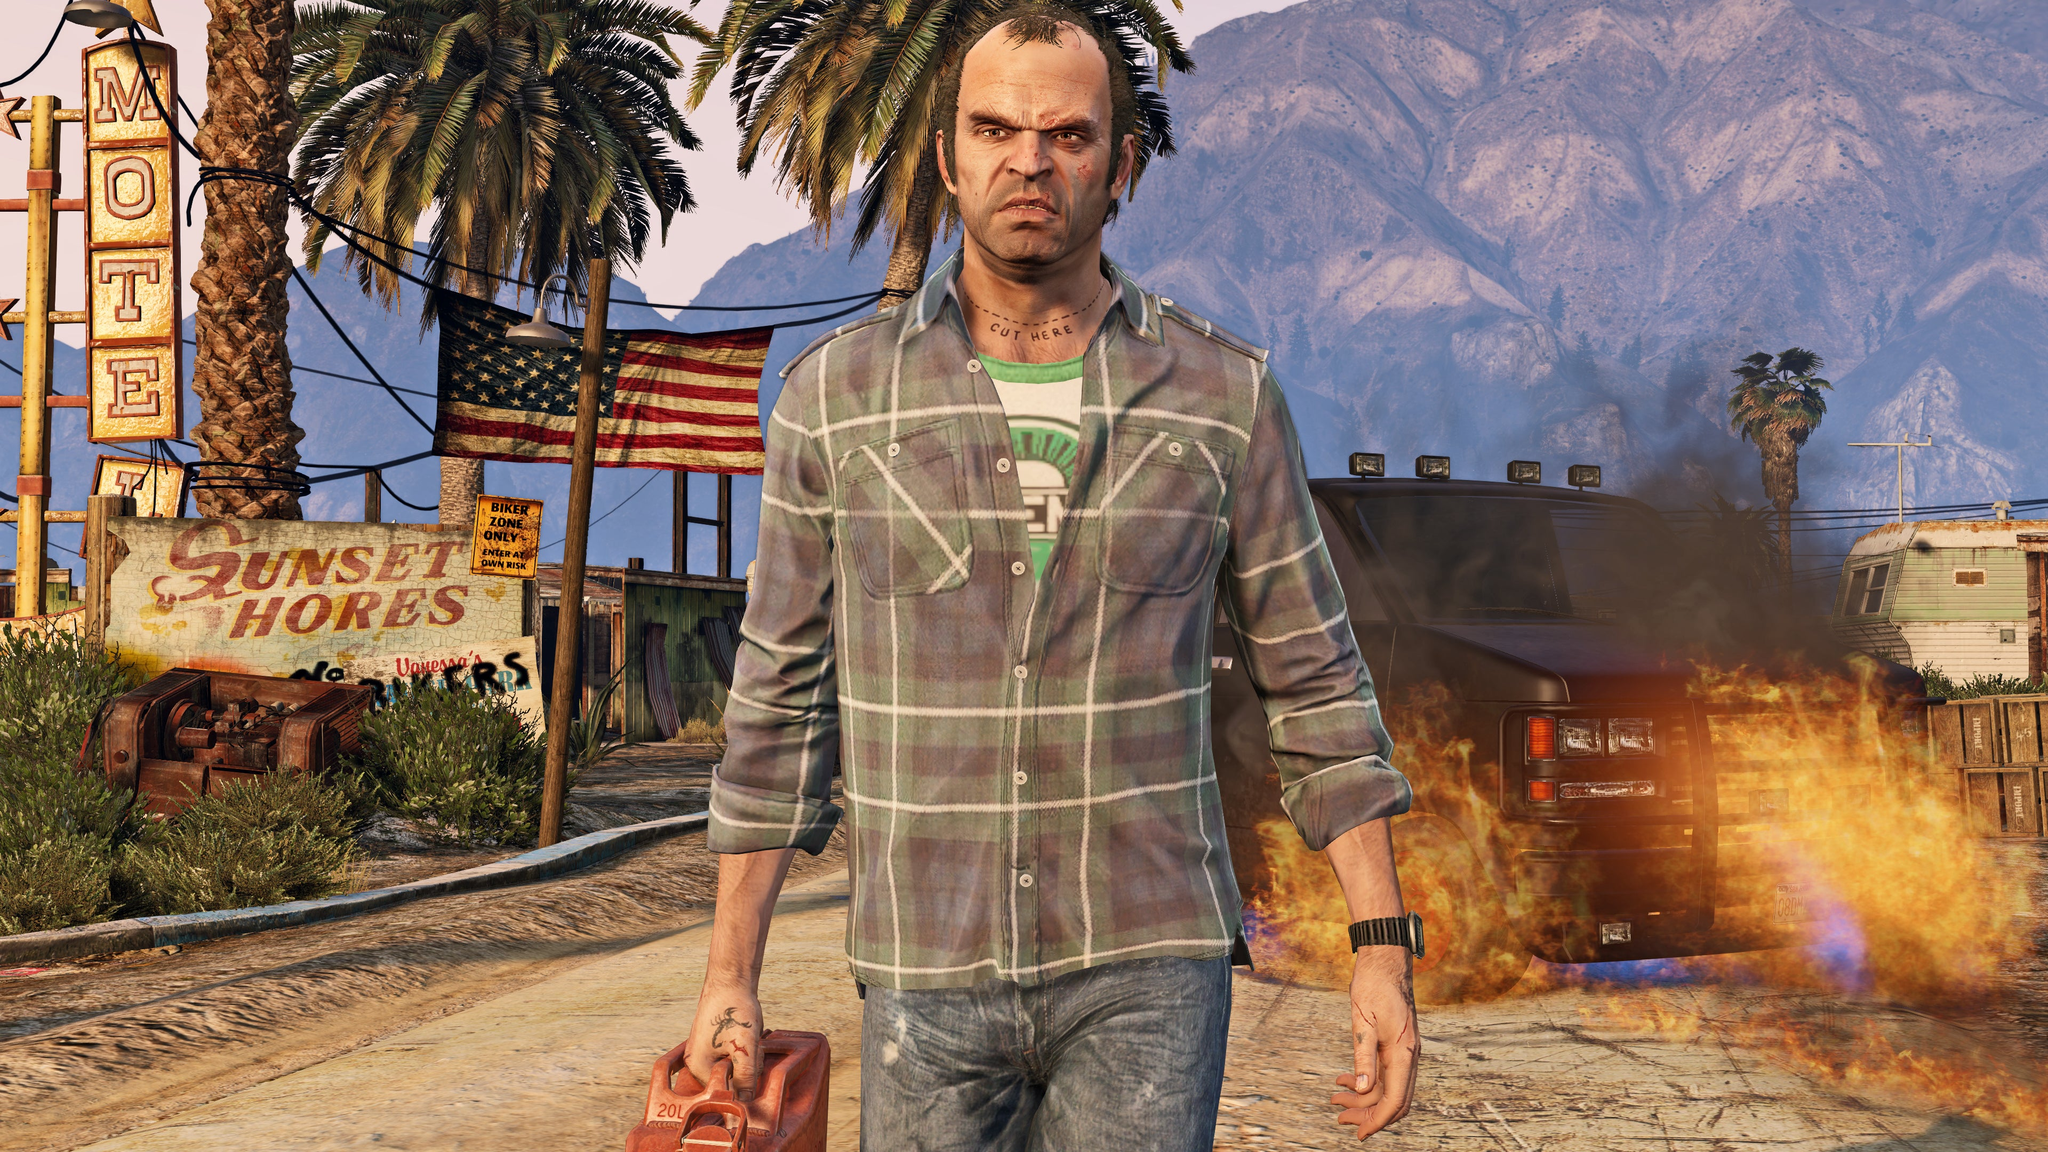What might the unattended fire in the image indicate about the current state of this area? The unattended fire in the image suggests a sense of abandonment or neglect in the area. It indicates that there might be a lack of adequate supervision or public safety measures. This scene portrays an environment where chaos or lawlessness could prevail, further hinting at economic or social decline. The fire could symbolize deeper underlying issues such as poor infrastructure maintenance or dwindling community engagement. 